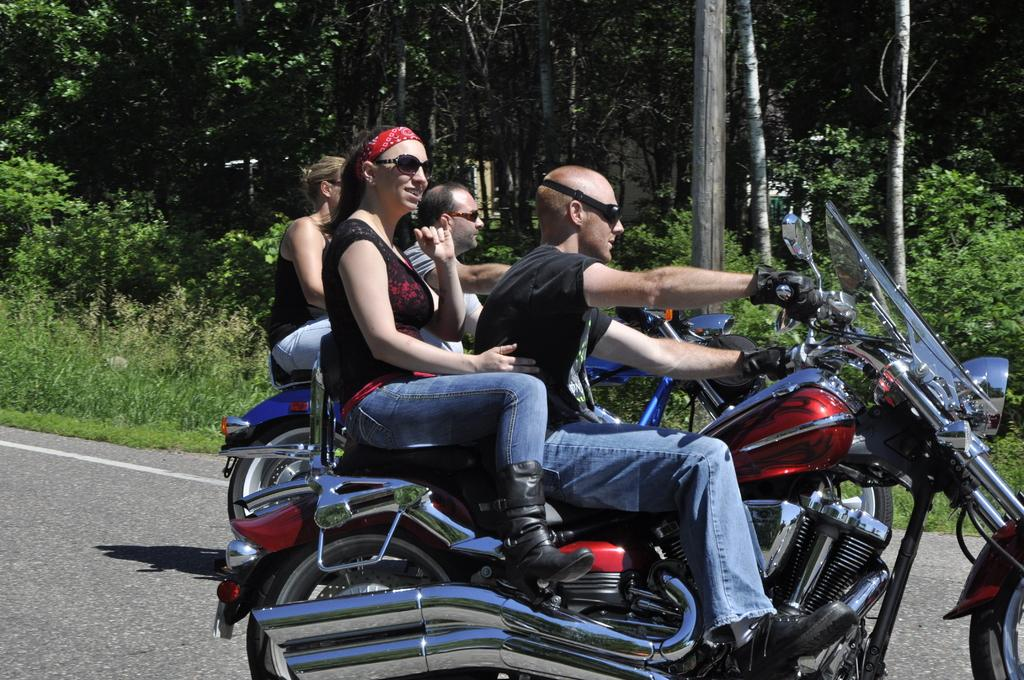How many bikes are in the image? There are two bikes in the image. How many people are on each bike? Two people are seated on each bike. Where are the bikes located? The bikes are on a road. What can be seen in the background of the image? There are trees visible in the background. Can you see a woman making a request to close the curtain in the image? There is no woman or curtain present in the image. 